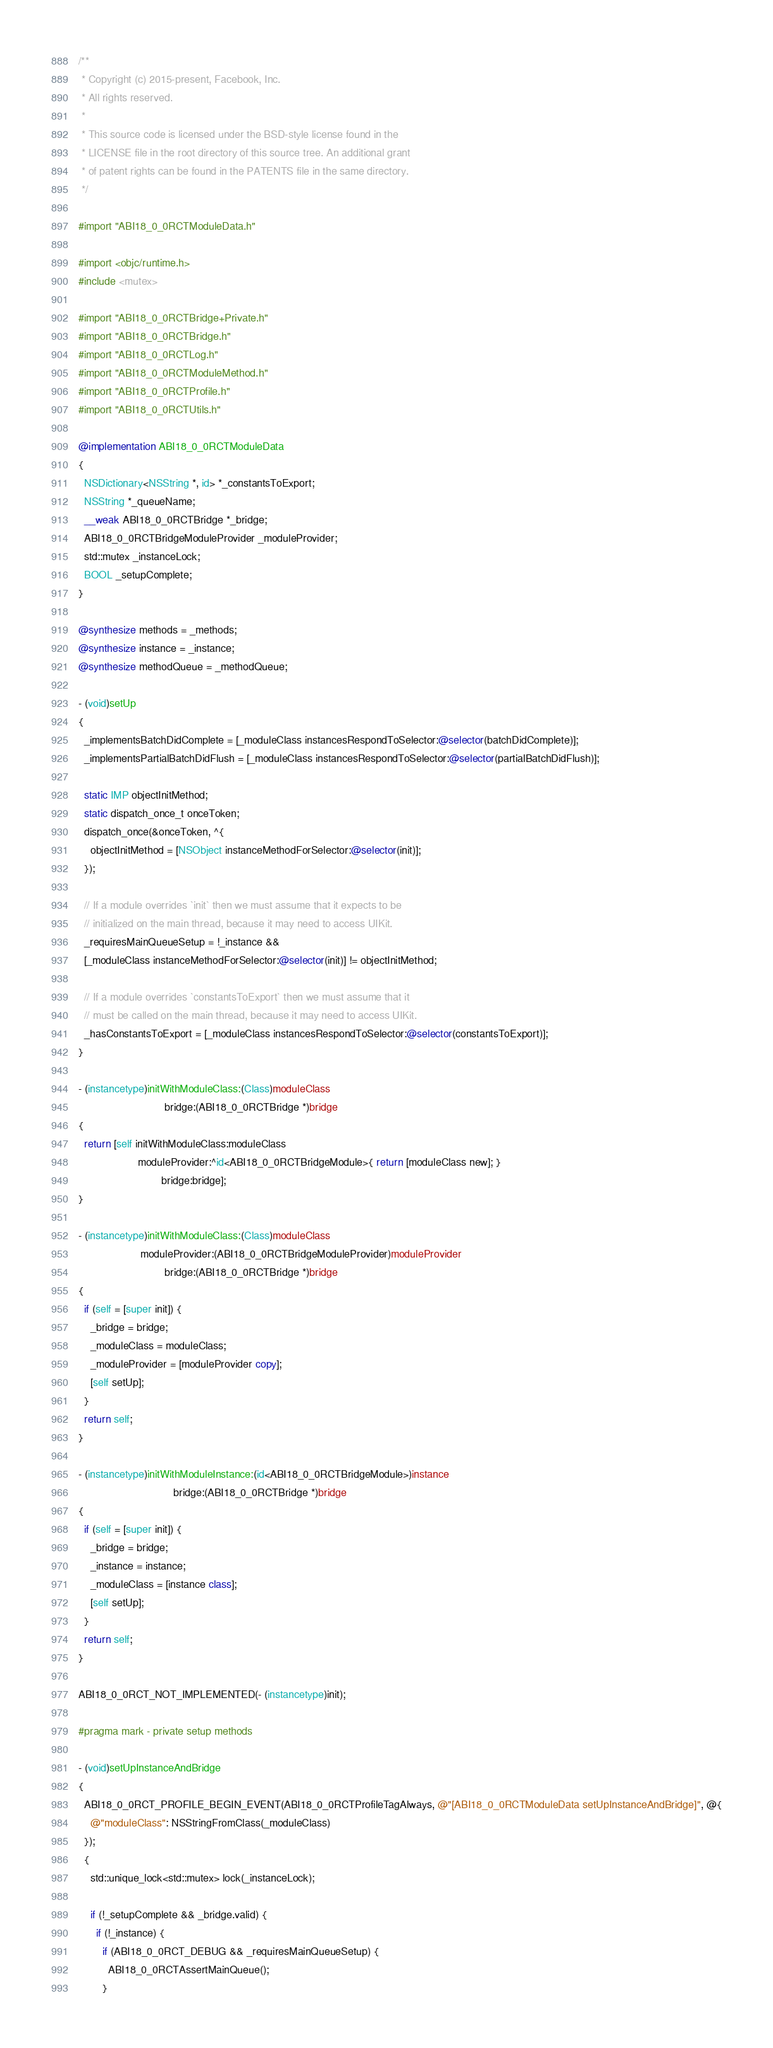Convert code to text. <code><loc_0><loc_0><loc_500><loc_500><_ObjectiveC_>/**
 * Copyright (c) 2015-present, Facebook, Inc.
 * All rights reserved.
 *
 * This source code is licensed under the BSD-style license found in the
 * LICENSE file in the root directory of this source tree. An additional grant
 * of patent rights can be found in the PATENTS file in the same directory.
 */

#import "ABI18_0_0RCTModuleData.h"

#import <objc/runtime.h>
#include <mutex>

#import "ABI18_0_0RCTBridge+Private.h"
#import "ABI18_0_0RCTBridge.h"
#import "ABI18_0_0RCTLog.h"
#import "ABI18_0_0RCTModuleMethod.h"
#import "ABI18_0_0RCTProfile.h"
#import "ABI18_0_0RCTUtils.h"

@implementation ABI18_0_0RCTModuleData
{
  NSDictionary<NSString *, id> *_constantsToExport;
  NSString *_queueName;
  __weak ABI18_0_0RCTBridge *_bridge;
  ABI18_0_0RCTBridgeModuleProvider _moduleProvider;
  std::mutex _instanceLock;
  BOOL _setupComplete;
}

@synthesize methods = _methods;
@synthesize instance = _instance;
@synthesize methodQueue = _methodQueue;

- (void)setUp
{
  _implementsBatchDidComplete = [_moduleClass instancesRespondToSelector:@selector(batchDidComplete)];
  _implementsPartialBatchDidFlush = [_moduleClass instancesRespondToSelector:@selector(partialBatchDidFlush)];

  static IMP objectInitMethod;
  static dispatch_once_t onceToken;
  dispatch_once(&onceToken, ^{
    objectInitMethod = [NSObject instanceMethodForSelector:@selector(init)];
  });

  // If a module overrides `init` then we must assume that it expects to be
  // initialized on the main thread, because it may need to access UIKit.
  _requiresMainQueueSetup = !_instance &&
  [_moduleClass instanceMethodForSelector:@selector(init)] != objectInitMethod;

  // If a module overrides `constantsToExport` then we must assume that it
  // must be called on the main thread, because it may need to access UIKit.
  _hasConstantsToExport = [_moduleClass instancesRespondToSelector:@selector(constantsToExport)];
}

- (instancetype)initWithModuleClass:(Class)moduleClass
                             bridge:(ABI18_0_0RCTBridge *)bridge
{
  return [self initWithModuleClass:moduleClass
                    moduleProvider:^id<ABI18_0_0RCTBridgeModule>{ return [moduleClass new]; }
                            bridge:bridge];
}

- (instancetype)initWithModuleClass:(Class)moduleClass
                     moduleProvider:(ABI18_0_0RCTBridgeModuleProvider)moduleProvider
                             bridge:(ABI18_0_0RCTBridge *)bridge
{
  if (self = [super init]) {
    _bridge = bridge;
    _moduleClass = moduleClass;
    _moduleProvider = [moduleProvider copy];
    [self setUp];
  }
  return self;
}

- (instancetype)initWithModuleInstance:(id<ABI18_0_0RCTBridgeModule>)instance
                                bridge:(ABI18_0_0RCTBridge *)bridge
{
  if (self = [super init]) {
    _bridge = bridge;
    _instance = instance;
    _moduleClass = [instance class];
    [self setUp];
  }
  return self;
}

ABI18_0_0RCT_NOT_IMPLEMENTED(- (instancetype)init);

#pragma mark - private setup methods

- (void)setUpInstanceAndBridge
{
  ABI18_0_0RCT_PROFILE_BEGIN_EVENT(ABI18_0_0RCTProfileTagAlways, @"[ABI18_0_0RCTModuleData setUpInstanceAndBridge]", @{
    @"moduleClass": NSStringFromClass(_moduleClass)
  });
  {
    std::unique_lock<std::mutex> lock(_instanceLock);

    if (!_setupComplete && _bridge.valid) {
      if (!_instance) {
        if (ABI18_0_0RCT_DEBUG && _requiresMainQueueSetup) {
          ABI18_0_0RCTAssertMainQueue();
        }</code> 